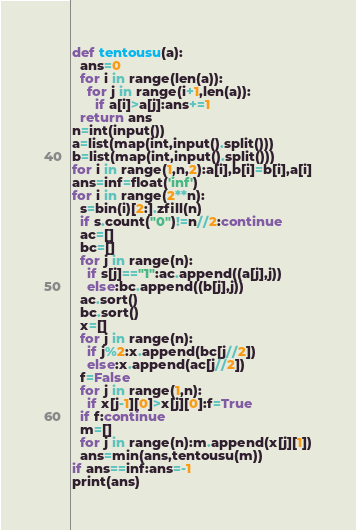Convert code to text. <code><loc_0><loc_0><loc_500><loc_500><_Python_>def tentousu(a):
  ans=0
  for i in range(len(a)):
    for j in range(i+1,len(a)):
      if a[i]>a[j]:ans+=1
  return ans
n=int(input())
a=list(map(int,input().split()))
b=list(map(int,input().split()))
for i in range(1,n,2):a[i],b[i]=b[i],a[i]
ans=inf=float('inf')
for i in range(2**n):
  s=bin(i)[2:].zfill(n)
  if s.count("0")!=n//2:continue
  ac=[]
  bc=[]
  for j in range(n):
    if s[j]=="1":ac.append((a[j],j))
    else:bc.append((b[j],j))
  ac.sort()
  bc.sort()
  x=[]
  for j in range(n):
    if j%2:x.append(bc[j//2])
    else:x.append(ac[j//2])
  f=False
  for j in range(1,n):
    if x[j-1][0]>x[j][0]:f=True
  if f:continue
  m=[]
  for j in range(n):m.append(x[j][1])
  ans=min(ans,tentousu(m))
if ans==inf:ans=-1
print(ans)
</code> 